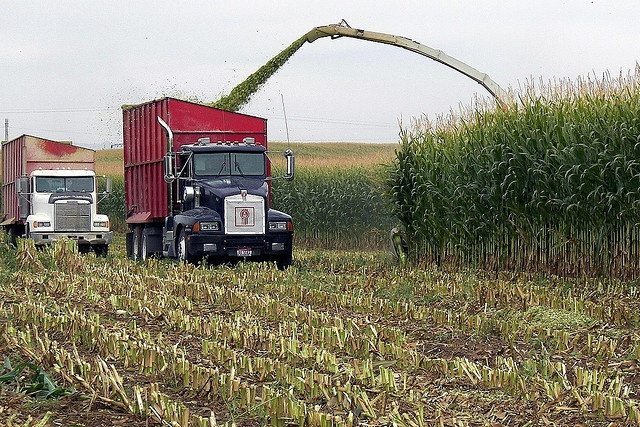Describe the objects in this image and their specific colors. I can see truck in white, black, gray, maroon, and darkgray tones and truck in white, gray, darkgray, and black tones in this image. 